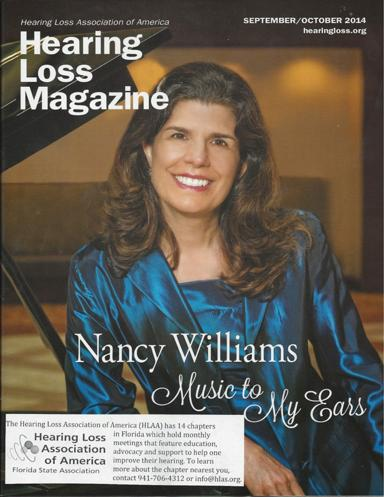What insights might this magazine provide for those new to hearing loss? This magazine likely offers a wealth of information including coping strategies, latest technological advancements in hearing aids, and firsthand accounts that can greatly benefit those who are newly experiencing hearing loss. 